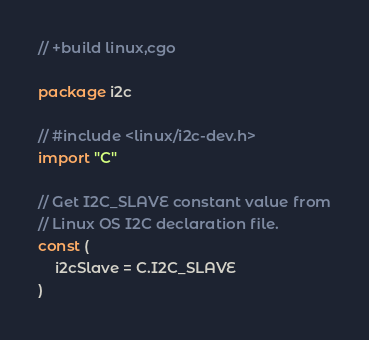Convert code to text. <code><loc_0><loc_0><loc_500><loc_500><_Go_>// +build linux,cgo

package i2c

// #include <linux/i2c-dev.h>
import "C"

// Get I2C_SLAVE constant value from
// Linux OS I2C declaration file.
const (
	i2cSlave = C.I2C_SLAVE
)
</code> 